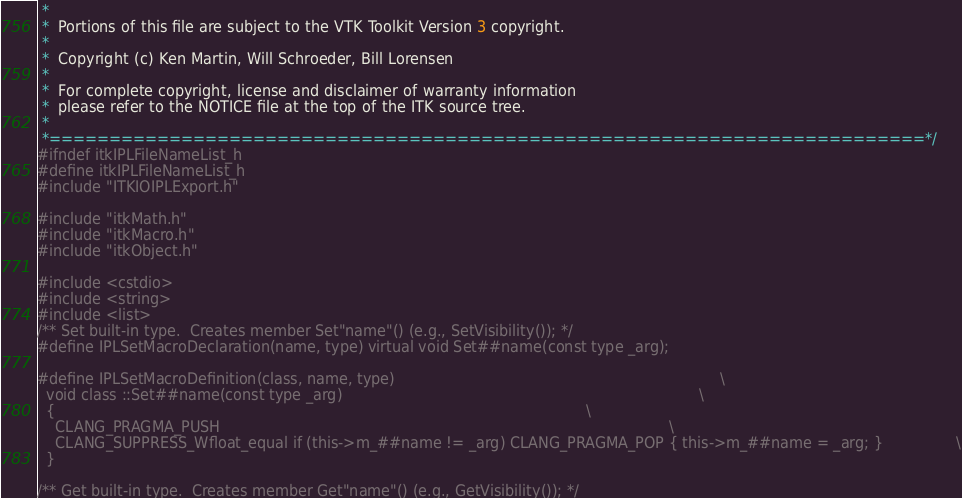Convert code to text. <code><loc_0><loc_0><loc_500><loc_500><_C_> *
 *  Portions of this file are subject to the VTK Toolkit Version 3 copyright.
 *
 *  Copyright (c) Ken Martin, Will Schroeder, Bill Lorensen
 *
 *  For complete copyright, license and disclaimer of warranty information
 *  please refer to the NOTICE file at the top of the ITK source tree.
 *
 *=========================================================================*/
#ifndef itkIPLFileNameList_h
#define itkIPLFileNameList_h
#include "ITKIOIPLExport.h"

#include "itkMath.h"
#include "itkMacro.h"
#include "itkObject.h"

#include <cstdio>
#include <string>
#include <list>
/** Set built-in type.  Creates member Set"name"() (e.g., SetVisibility()); */
#define IPLSetMacroDeclaration(name, type) virtual void Set##name(const type _arg);

#define IPLSetMacroDefinition(class, name, type)                                                                       \
  void class ::Set##name(const type _arg)                                                                              \
  {                                                                                                                    \
    CLANG_PRAGMA_PUSH                                                                                                  \
    CLANG_SUPPRESS_Wfloat_equal if (this->m_##name != _arg) CLANG_PRAGMA_POP { this->m_##name = _arg; }                \
  }

/** Get built-in type.  Creates member Get"name"() (e.g., GetVisibility()); */</code> 